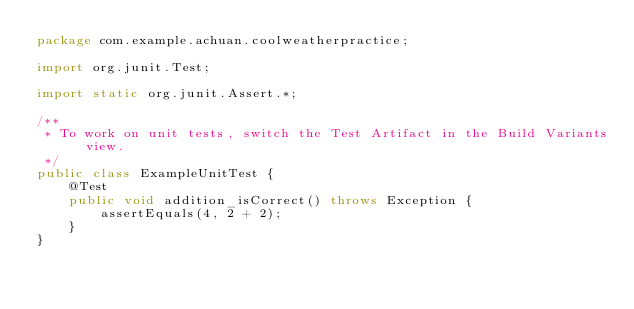Convert code to text. <code><loc_0><loc_0><loc_500><loc_500><_Java_>package com.example.achuan.coolweatherpractice;

import org.junit.Test;

import static org.junit.Assert.*;

/**
 * To work on unit tests, switch the Test Artifact in the Build Variants view.
 */
public class ExampleUnitTest {
    @Test
    public void addition_isCorrect() throws Exception {
        assertEquals(4, 2 + 2);
    }
}</code> 